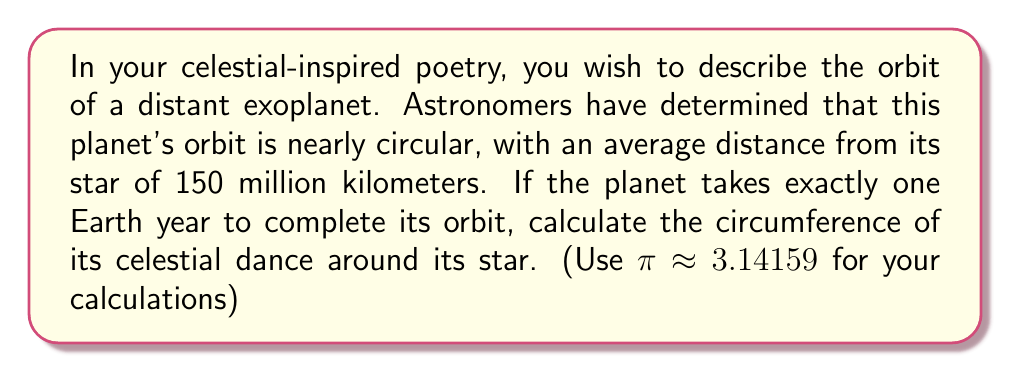Can you solve this math problem? To solve this problem, we'll use the formula for the circumference of a circle, as the planet's orbit is described as nearly circular. The steps are as follows:

1) The formula for the circumference of a circle is:

   $$C = 2\pi r$$

   where $C$ is the circumference and $r$ is the radius.

2) In this case, the radius is the average distance from the planet to its star:
   
   $r = 150$ million km

3) Substituting this into our formula:

   $$C = 2\pi (150,000,000 \text{ km})$$

4) Now, let's calculate:

   $$C = 2 \cdot 3.14159 \cdot 150,000,000 \text{ km}$$
   $$C = 942,477,000 \text{ km}$$

5) Rounding to 3 significant figures:

   $$C \approx 942,000,000 \text{ km}$$

This result represents the distance the planet travels in its orbit over one Earth year.
Answer: The circumference of the planet's orbit is approximately 942,000,000 km. 